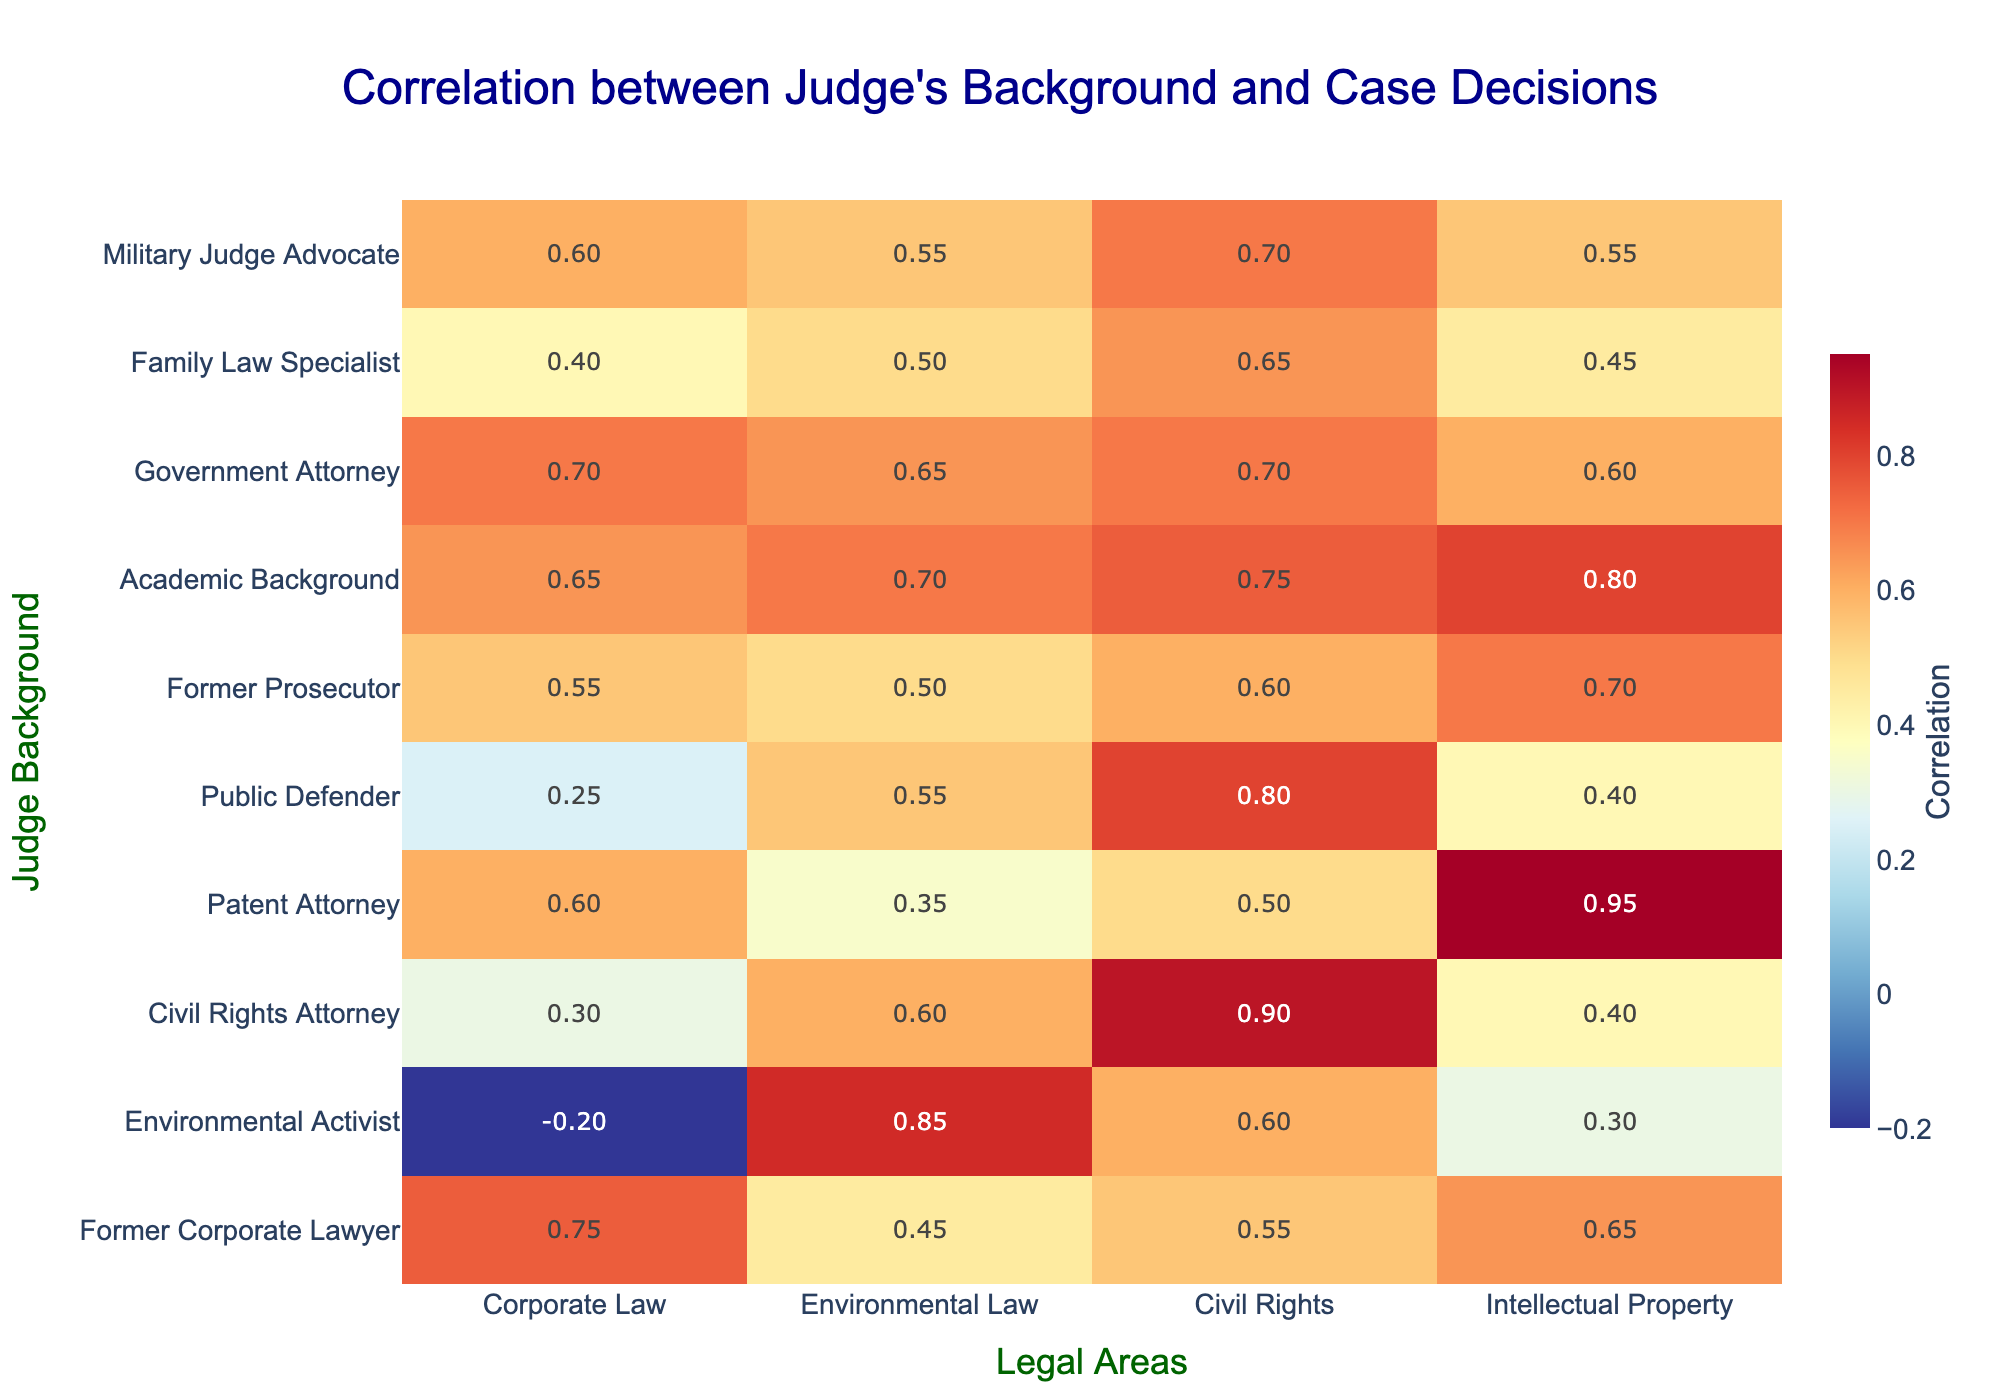What is the correlation value for Environmental Law from the perspective of a Civil Rights Attorney? According to the table, the correlation value for Environmental Law associated with a Civil Rights Attorney is 0.60.
Answer: 0.60 Which judge background has the highest correlation with Intellectual Property? The table shows that the Patent Attorney has the highest correlation with Intellectual Property, with a value of 0.95.
Answer: Patent Attorney What is the average correlation value for judges with a background in Corporate Law? To find the average, we take the correlation values for Corporate Law: 0.75 (Former Corporate Lawyer), -0.20 (Environmental Activist), 0.30 (Civil Rights Attorney), 0.60 (Patent Attorney), 0.25 (Public Defender), 0.55 (Former Prosecutor), 0.65 (Academic Background), 0.70 (Government Attorney), 0.40 (Family Law Specialist), 0.60 (Military Judge Advocate). The sum is 0.75 - 0.20 + 0.30 + 0.60 + 0.25 + 0.55 + 0.65 + 0.70 + 0.40 + 0.60 = 4.25. Dividing by 10 gives an average of 0.425.
Answer: 0.425 Does an Environmental Activist judge tend to favor Corporate Law decisions? The correlation value for Corporate Law from the perspective of an Environmental Activist is -0.20, indicating a negative correlation, which implies that they tend not to favor Corporate Law decisions.
Answer: No What is the difference in correlation values between a Public Defender and a Military Judge Advocate in Civil Rights? The correlation value for Civil Rights for a Public Defender is 0.80, and for a Military Judge Advocate, it is 0.70. The difference is 0.80 - 0.70 = 0.10.
Answer: 0.10 Which judge background shows the lowest correlation in Environmental Law? The Environmental Law correlation values are -0.20 (Former Corporate Lawyer), 0.85 (Environmental Activist), 0.60 (Civil Rights Attorney), 0.35 (Patent Attorney), 0.55 (Public Defender), 0.50 (Former Prosecutor), 0.70 (Academic Background), 0.65 (Government Attorney), 0.50 (Family Law Specialist), and 0.55 (Military Judge Advocate). The lowest value is -0.20 associated with a Former Corporate Lawyer.
Answer: Former Corporate Lawyer Are judges with an Academic Background more favorable toward Civil Rights than those who are Former Prosecutors? The correlation value for Civil Rights for Academic Background is 0.75 while it is 0.60 for Former Prosecutors. Since 0.75 is greater than 0.60, Academic Background judges show more favorability toward Civil Rights than Former Prosecutors.
Answer: Yes What is the total correlation value for all judges with a background in Intellectual Property? The values for Intellectual Property are 0.65 (Former Corporate Lawyer), 0.30 (Environmental Activist), 0.40 (Civil Rights Attorney), 0.95 (Patent Attorney), 0.40 (Public Defender), 0.70 (Former Prosecutor), 0.80 (Academic Background), 0.60 (Government Attorney), 0.45 (Family Law Specialist), and 0.55 (Military Judge Advocate). Adding these gives 0.65 + 0.30 + 0.40 + 0.95 + 0.40 + 0.70 + 0.80 + 0.60 + 0.45 + 0.55 = 5.70.
Answer: 5.70 Which judge background correlates positively with all areas of law listed? By reviewing the table, only the Academic Background shows positive correlations across all areas: 0.65 (Corporate Law), 0.70 (Environmental Law), 0.75 (Civil Rights), and 0.80 (Intellectual Property).
Answer: Academic Background What is the correlation value trend for a Civil Rights Attorney across different legal areas? The correlation values for a Civil Rights Attorney are: 0.30 (Corporate Law), 0.60 (Environmental Law), 0.90 (Civil Rights), and 0.40 (Intellectual Property). The trend shows increasing from Corporate Law to Civil Rights, then decreasing towards Intellectual Property.
Answer: Increasing then decreasing 